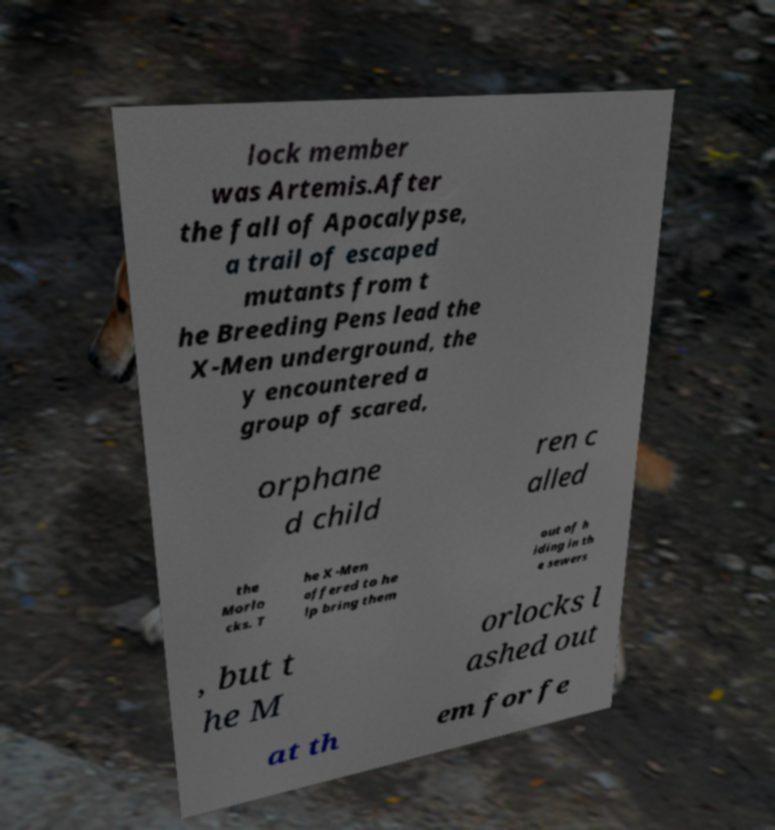I need the written content from this picture converted into text. Can you do that? lock member was Artemis.After the fall of Apocalypse, a trail of escaped mutants from t he Breeding Pens lead the X-Men underground, the y encountered a group of scared, orphane d child ren c alled the Morlo cks. T he X-Men offered to he lp bring them out of h iding in th e sewers , but t he M orlocks l ashed out at th em for fe 